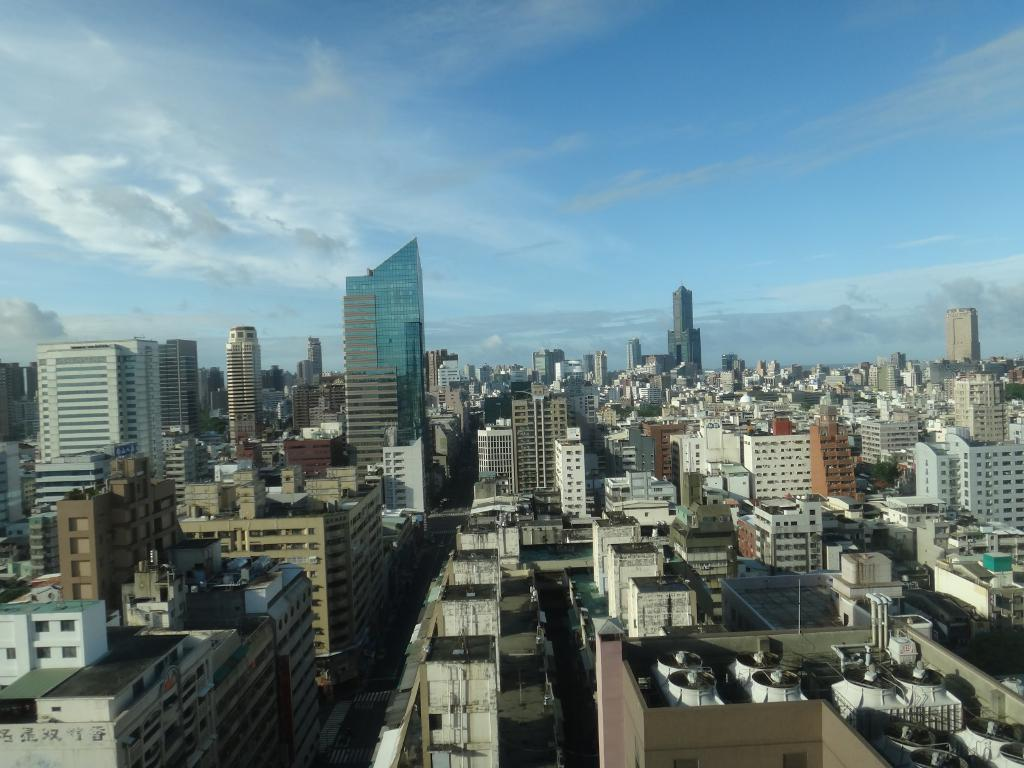What is the main subject of the image? The main subject of the image is a group of buildings. What feature do the buildings have? The buildings have windows. What can be seen in the background of the image? The sky is visible in the image. How would you describe the sky in the image? The sky appears to be cloudy. What type of van is parked in front of the buildings in the image? There is no van present in the image; it only features a group of buildings with windows. What army is depicted in the image? There is no army present in the image; it only features a group of buildings with windows and a cloudy sky. 